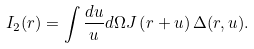<formula> <loc_0><loc_0><loc_500><loc_500>I _ { 2 } ( { r } ) = \int \frac { d u } { u } d \Omega J \left ( { r } + { u } \right ) { \Delta } ( { r } , { u } ) .</formula> 